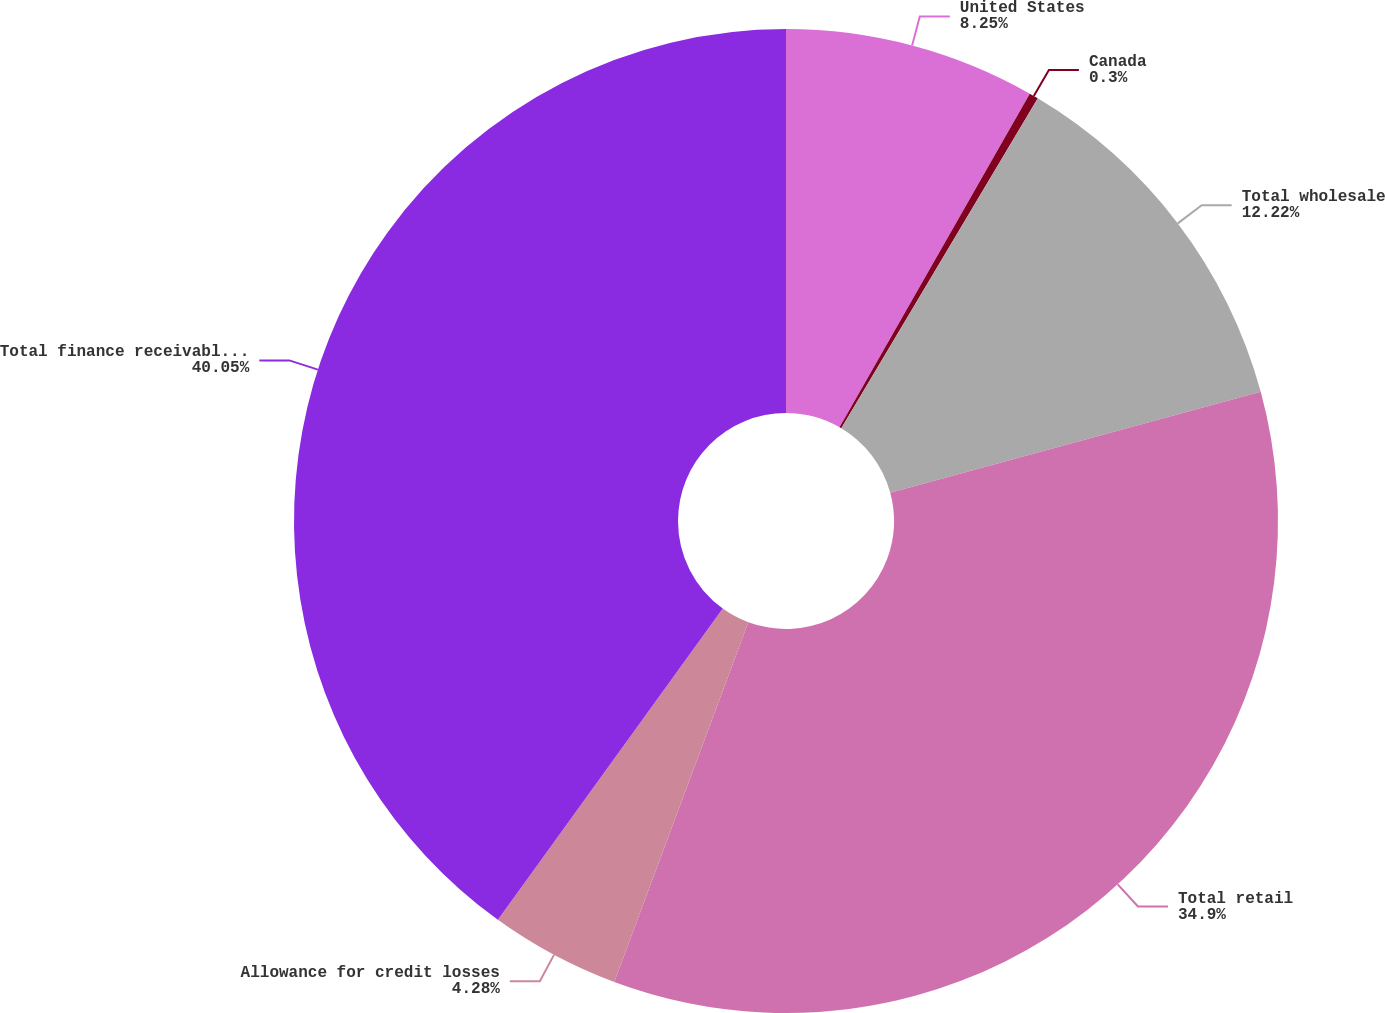<chart> <loc_0><loc_0><loc_500><loc_500><pie_chart><fcel>United States<fcel>Canada<fcel>Total wholesale<fcel>Total retail<fcel>Allowance for credit losses<fcel>Total finance receivables net<nl><fcel>8.25%<fcel>0.3%<fcel>12.22%<fcel>34.9%<fcel>4.28%<fcel>40.04%<nl></chart> 